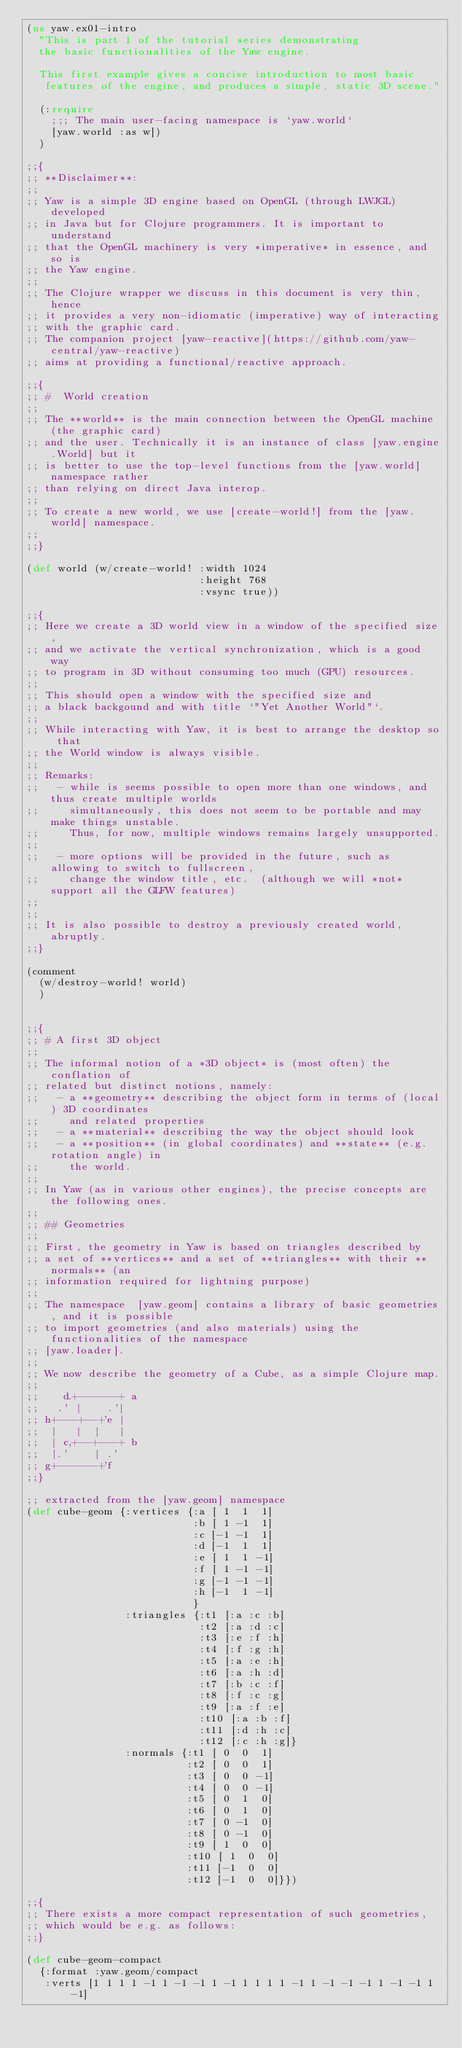<code> <loc_0><loc_0><loc_500><loc_500><_Clojure_>(ns yaw.ex01-intro
  "This is part 1 of the tutorial series demonstrating
  the basic functionalities of the Yaw engine.

  This first example gives a concise introduction to most basic
   features of the engine, and produces a simple, static 3D scene."

  (:require
    ;;; The main user-facing namespace is `yaw.world`
    [yaw.world :as w])
  )

;;{
;; **Disclaimer**:
;;
;; Yaw is a simple 3D engine based on OpenGL (through LWJGL) developed
;; in Java but for Clojure programmers. It is important to understand
;; that the OpenGL machinery is very *imperative* in essence, and so is
;; the Yaw engine.
;;
;; The Clojure wrapper we discuss in this document is very thin, hence
;; it provides a very non-idiomatic (imperative) way of interacting
;; with the graphic card.
;; The companion project [yaw-reactive](https://github.com/yaw-central/yaw-reactive)
;; aims at providing a functional/reactive approach.

;;{
;; #  World creation
;;
;; The **world** is the main connection between the OpenGL machine (the graphic card)
;; and the user. Technically it is an instance of class [yaw.engine.World] but it
;; is better to use the top-level functions from the [yaw.world] namespace rather
;; than relying on direct Java interop.
;;
;; To create a new world, we use [create-world!] from the [yaw.world] namespace.
;;
;;}

(def world (w/create-world! :width 1024
                            :height 768
                            :vsync true))

;;{
;; Here we create a 3D world view in a window of the specified size,
;; and we activate the vertical synchronization, which is a good way
;; to program in 3D without consuming too much (GPU) resources.
;;
;; This should open a window with the specified size and
;; a black backgound and with title `"Yet Another World"`.
;;
;; While interacting with Yaw, it is best to arrange the desktop so that
;; the World window is always visible.
;;
;; Remarks:
;;   - while is seems possible to open more than one windows, and thus create multiple worlds
;;     simultaneously, this does not seem to be portable and may make things unstable.
;;     Thus, for now, multiple windows remains largely unsupported.
;;
;;   - more options will be provided in the future, such as allowing to switch to fullscreen,
;;     change the window title, etc.  (although we will *not* support all the GLFW features)
;;
;;
;; It is also possible to destroy a previously created world, abruptly.
;;}

(comment
  (w/destroy-world! world)
  )


;;{
;; # A first 3D object
;;
;; The informal notion of a *3D object* is (most often) the conflation of
;; related but distinct notions, namely:
;;   - a **geometry** describing the object form in terms of (local) 3D coordinates
;;     and related properties
;;   - a **material** describing the way the object should look
;;   - a **position** (in global coordinates) and **state** (e.g. rotation angle) in
;;     the world.
;;
;; In Yaw (as in various other engines), the precise concepts are the following ones.
;;
;; ## Geometries
;;
;; First, the geometry in Yaw is based on triangles described by
;; a set of **vertices** and a set of **triangles** with their **normals** (an
;; information required for lightning purpose)
;;
;; The namespace  [yaw.geom] contains a library of basic geometries, and it is possible
;; to import geometries (and also materials) using the functionalities of the namespace
;; [yaw.loader].
;;
;; We now describe the geometry of a Cube, as a simple Clojure map.
;;
;;    d.+------+ a
;;   .' |    .'|
;; h+---+--+'e |
;;  |   |  |   |
;;  | c,+--+---+ b
;;  |.'    | .'
;; g+------+'f
;;}

;; extracted from the [yaw.geom] namespace
(def cube-geom {:vertices {:a [ 1  1  1]
                           :b [ 1 -1  1]
                           :c [-1 -1  1]
                           :d [-1  1  1]
                           :e [ 1  1 -1]
                           :f [ 1 -1 -1]
                           :g [-1 -1 -1]
                           :h [-1  1 -1]
                           }
                :triangles {:t1 [:a :c :b]
                            :t2 [:a :d :c]
                            :t3 [:e :f :h]
                            :t4 [:f :g :h]
                            :t5 [:a :e :h]
                            :t6 [:a :h :d]
                            :t7 [:b :c :f]
                            :t8 [:f :c :g]
                            :t9 [:a :f :e]
                            :t10 [:a :b :f]
                            :t11 [:d :h :c]
                            :t12 [:c :h :g]}
                :normals {:t1 [ 0  0  1]
                          :t2 [ 0  0  1]
                          :t3 [ 0  0 -1]
                          :t4 [ 0  0 -1]
                          :t5 [ 0  1  0]
                          :t6 [ 0  1  0]
                          :t7 [ 0 -1  0]
                          :t8 [ 0 -1  0]
                          :t9 [ 1  0  0]
                          :t10 [ 1  0  0]
                          :t11 [-1  0  0]
                          :t12 [-1  0  0]}})

;;{
;; There exists a more compact representation of such geometries,
;; which would be e.g. as follows:
;;}

(def cube-geom-compact
  {:format :yaw.geom/compact
   :verts [1 1 1 1 -1 1 -1 -1 1 -1 1 1 1 1 -1 1 -1 -1 -1 1 -1 -1 1 -1]</code> 